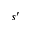<formula> <loc_0><loc_0><loc_500><loc_500>s ^ { \prime }</formula> 